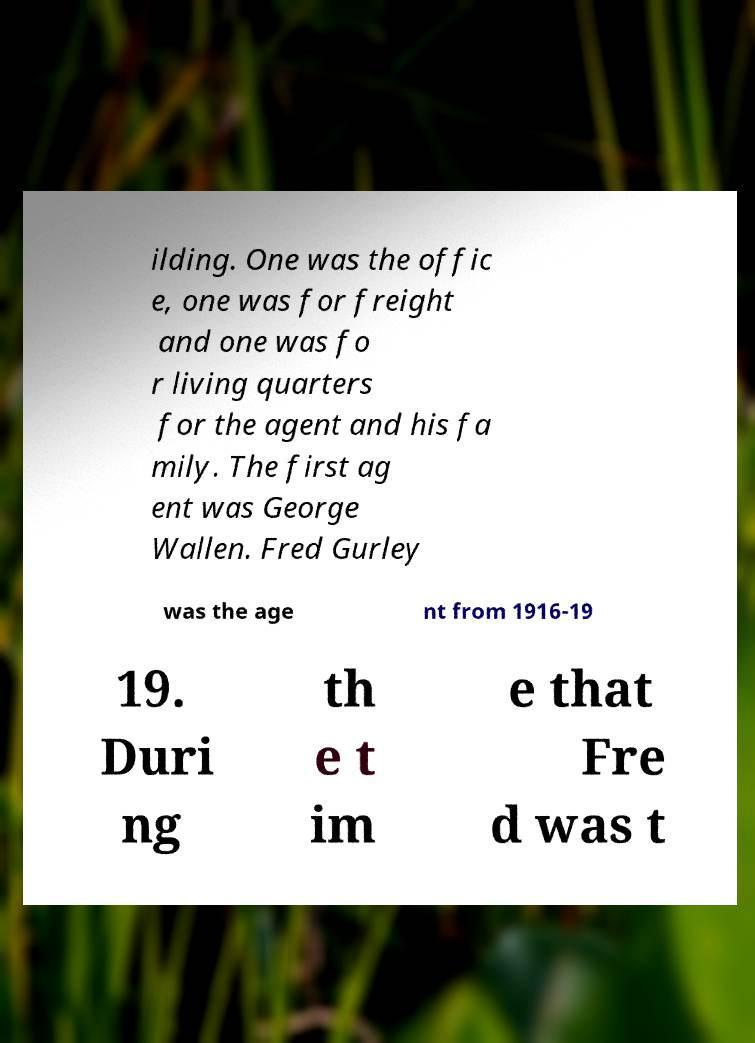Could you extract and type out the text from this image? ilding. One was the offic e, one was for freight and one was fo r living quarters for the agent and his fa mily. The first ag ent was George Wallen. Fred Gurley was the age nt from 1916-19 19. Duri ng th e t im e that Fre d was t 